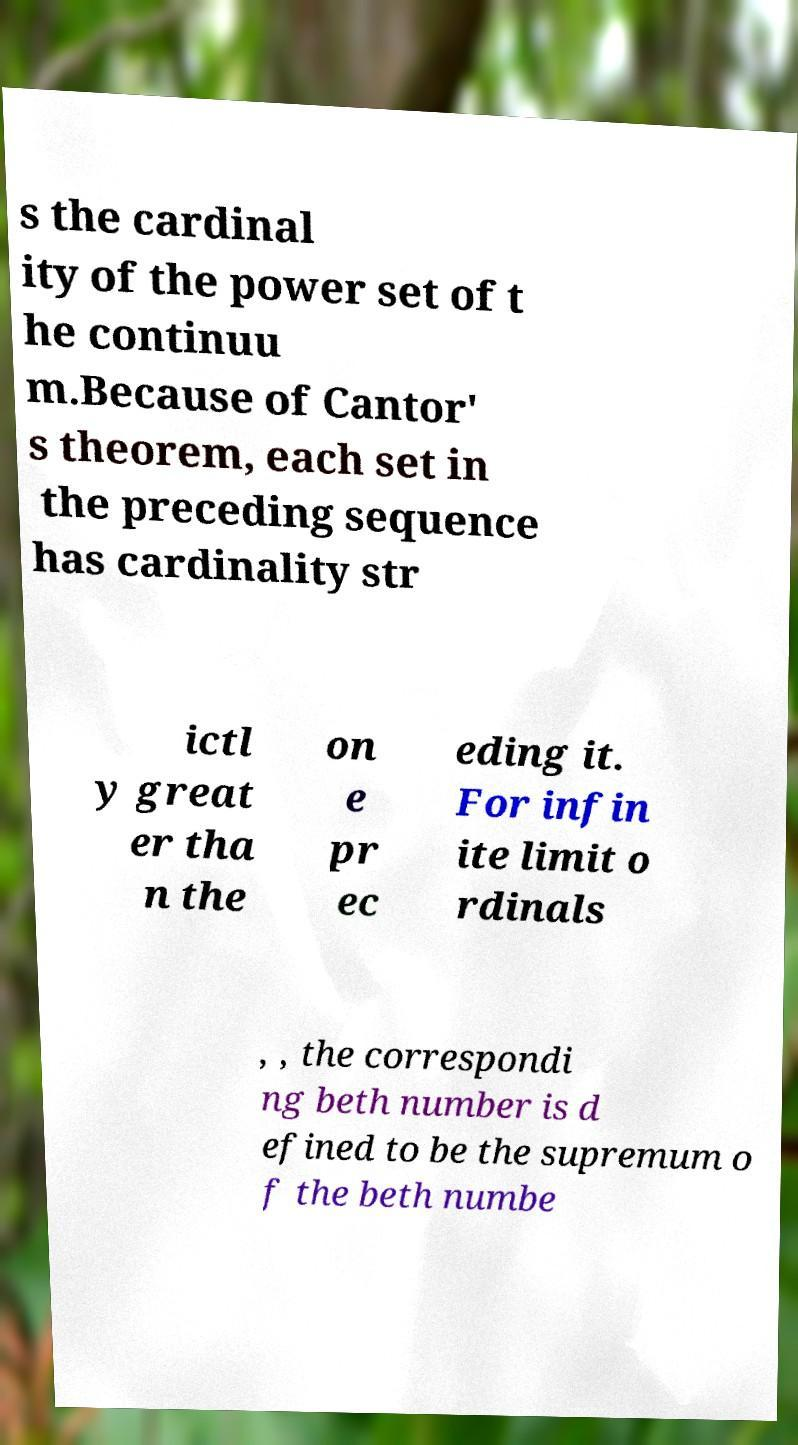Please read and relay the text visible in this image. What does it say? s the cardinal ity of the power set of t he continuu m.Because of Cantor' s theorem, each set in the preceding sequence has cardinality str ictl y great er tha n the on e pr ec eding it. For infin ite limit o rdinals , , the correspondi ng beth number is d efined to be the supremum o f the beth numbe 